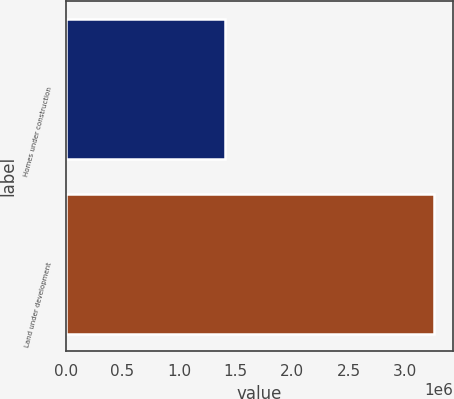<chart> <loc_0><loc_0><loc_500><loc_500><bar_chart><fcel>Homes under construction<fcel>Land under development<nl><fcel>1.40826e+06<fcel>3.25907e+06<nl></chart> 